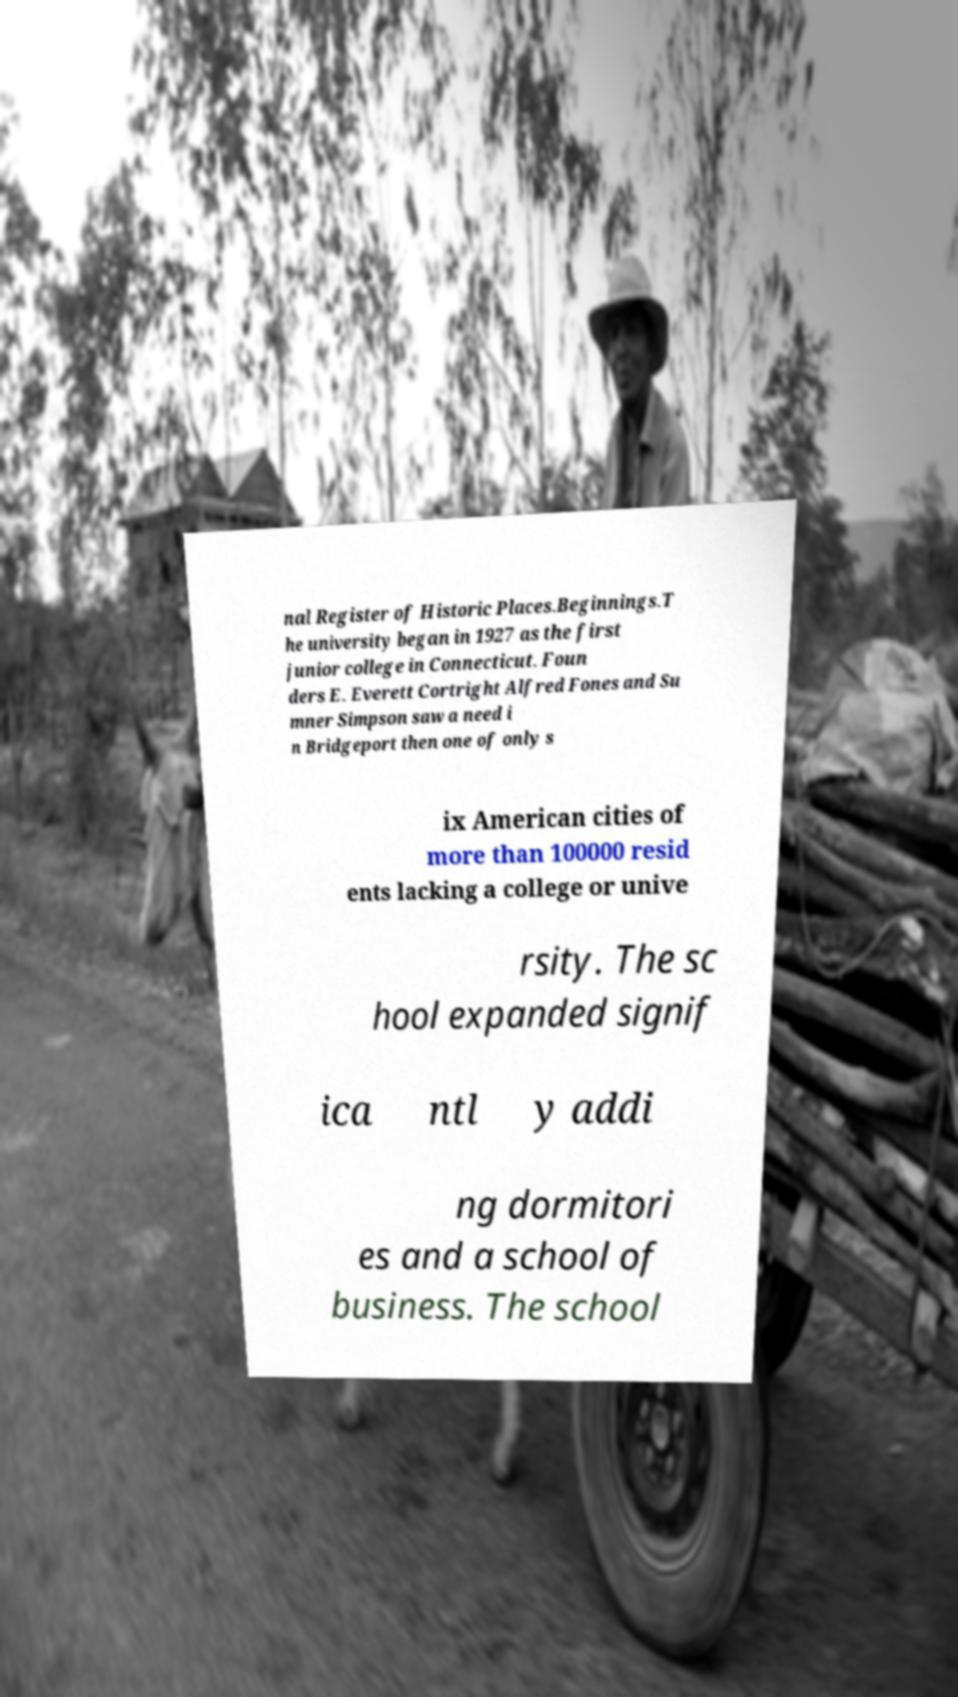I need the written content from this picture converted into text. Can you do that? nal Register of Historic Places.Beginnings.T he university began in 1927 as the first junior college in Connecticut. Foun ders E. Everett Cortright Alfred Fones and Su mner Simpson saw a need i n Bridgeport then one of only s ix American cities of more than 100000 resid ents lacking a college or unive rsity. The sc hool expanded signif ica ntl y addi ng dormitori es and a school of business. The school 